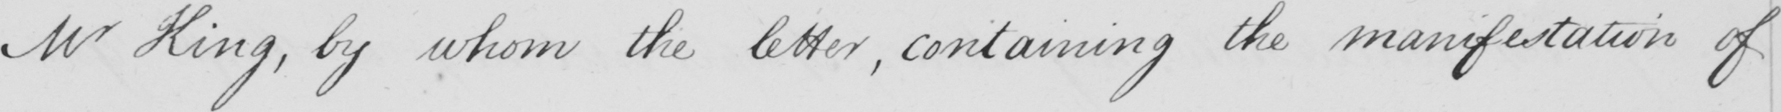Please provide the text content of this handwritten line. Mr King , by whom the letter , containing the manifestation of 